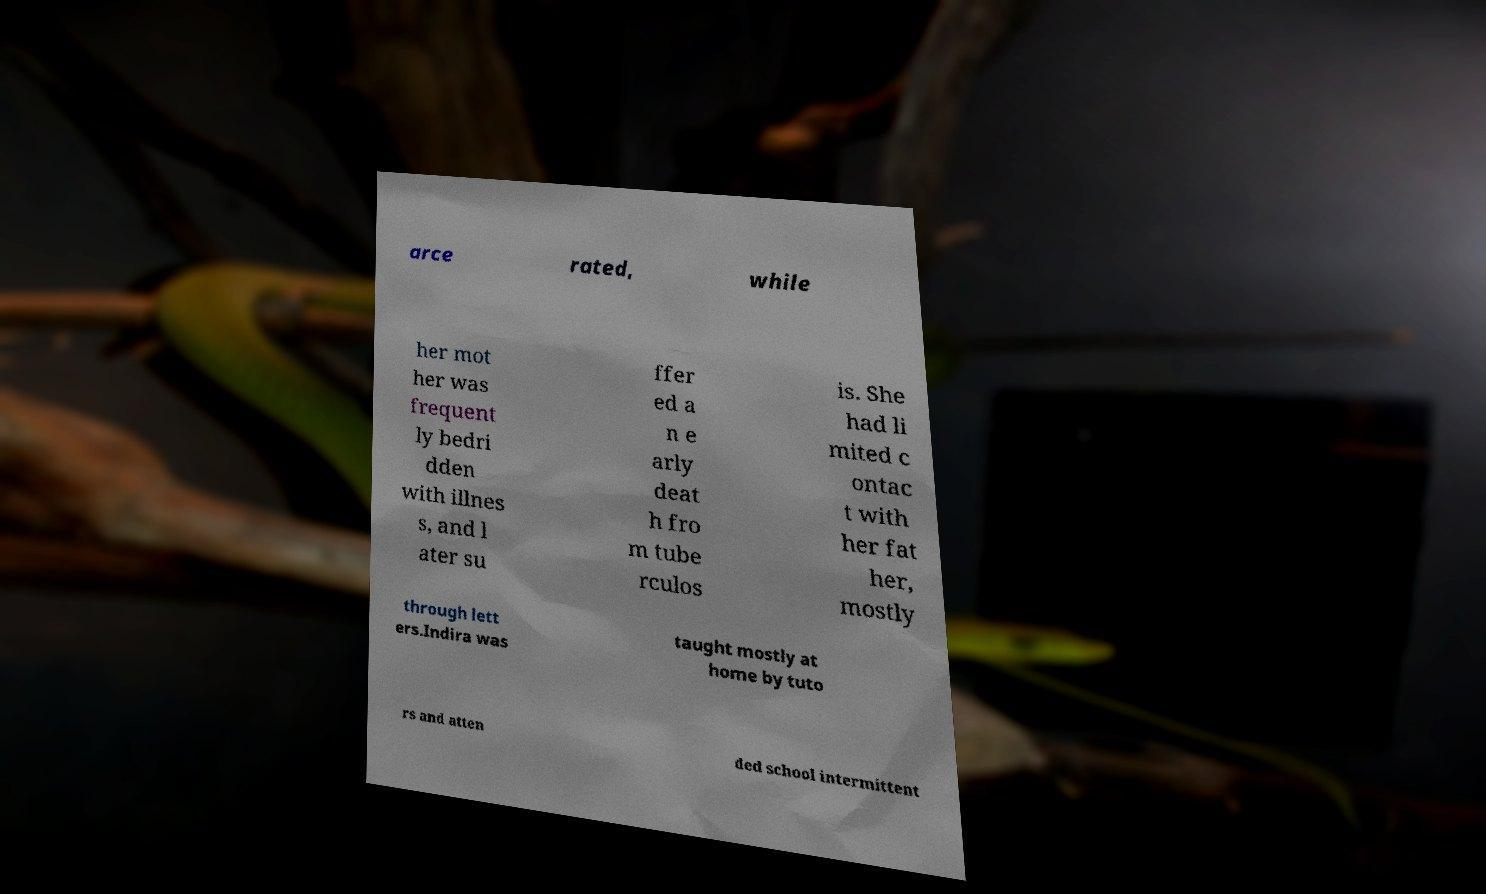I need the written content from this picture converted into text. Can you do that? arce rated, while her mot her was frequent ly bedri dden with illnes s, and l ater su ffer ed a n e arly deat h fro m tube rculos is. She had li mited c ontac t with her fat her, mostly through lett ers.Indira was taught mostly at home by tuto rs and atten ded school intermittent 